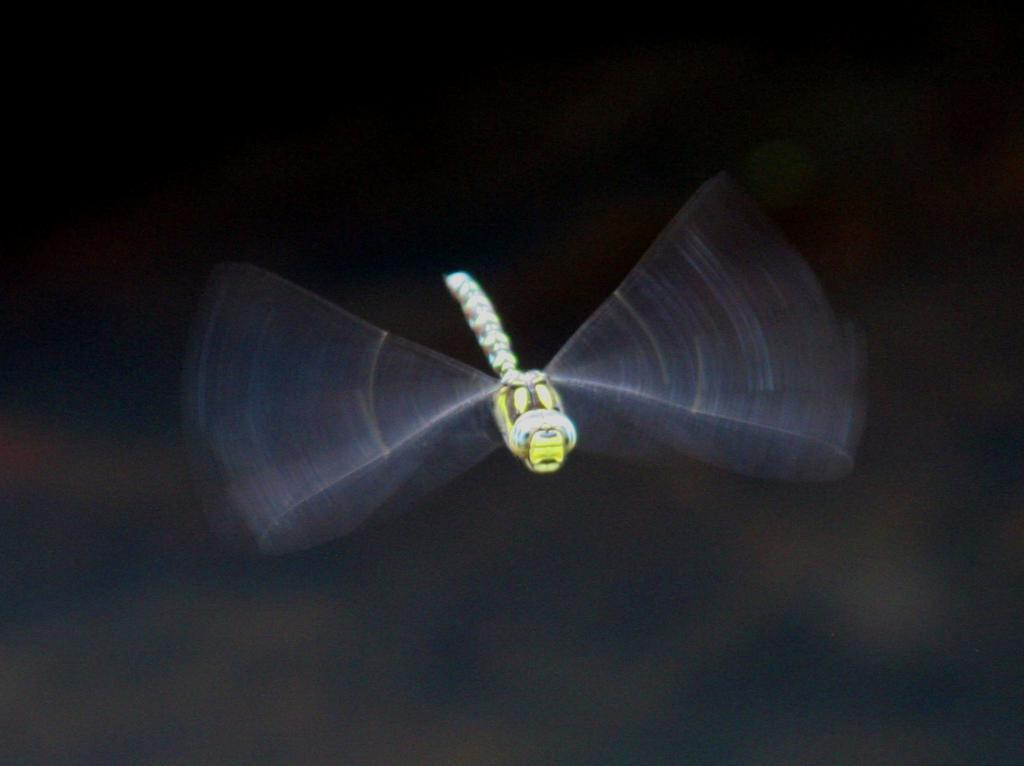What is the main subject of the picture? The main subject of the picture is a dragonfly. Can you describe the background of the image? The background of the image is blurred. Where is the grandmother sitting with her knitting in the image? There is no grandmother or knitting present in the image; it features a dragonfly. What type of icicle can be seen hanging from the dragonfly's wings in the image? There are no icicles present in the image; it features a dragonfly with no visible ice formations. 